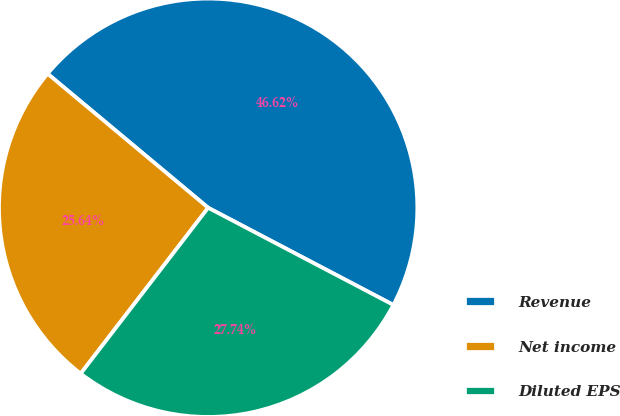Convert chart. <chart><loc_0><loc_0><loc_500><loc_500><pie_chart><fcel>Revenue<fcel>Net income<fcel>Diluted EPS<nl><fcel>46.62%<fcel>25.64%<fcel>27.74%<nl></chart> 